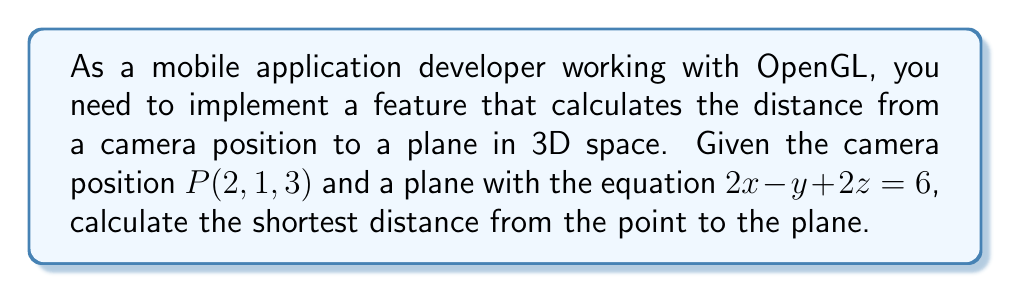Help me with this question. To calculate the distance from a point to a plane in 3D space, we can use the following formula:

$$d = \frac{|Ax_0 + By_0 + Cz_0 + D|}{\sqrt{A^2 + B^2 + C^2}}$$

Where $(x_0, y_0, z_0)$ are the coordinates of the point, and $Ax + By + Cz + D = 0$ is the equation of the plane.

Given:
- Point $P(2, 1, 3)$
- Plane equation: $2x - y + 2z = 6$

Step 1: Identify the coefficients A, B, C, and D from the plane equation.
$2x - y + 2z = 6$ can be rewritten as $2x - y + 2z - 6 = 0$
So, $A = 2$, $B = -1$, $C = 2$, and $D = -6$

Step 2: Substitute the values into the distance formula:
$$d = \frac{|2(2) + (-1)(1) + 2(3) + (-6)|}{\sqrt{2^2 + (-1)^2 + 2^2}}$$

Step 3: Simplify the numerator:
$$d = \frac{|4 - 1 + 6 - 6|}{\sqrt{4 + 1 + 4}}$$
$$d = \frac{|3|}{\sqrt{9}}$$

Step 4: Simplify the fraction:
$$d = \frac{3}{3} = 1$$

Therefore, the shortest distance from the point $P(2, 1, 3)$ to the plane $2x - y + 2z = 6$ is 1 unit.
Answer: 1 unit 